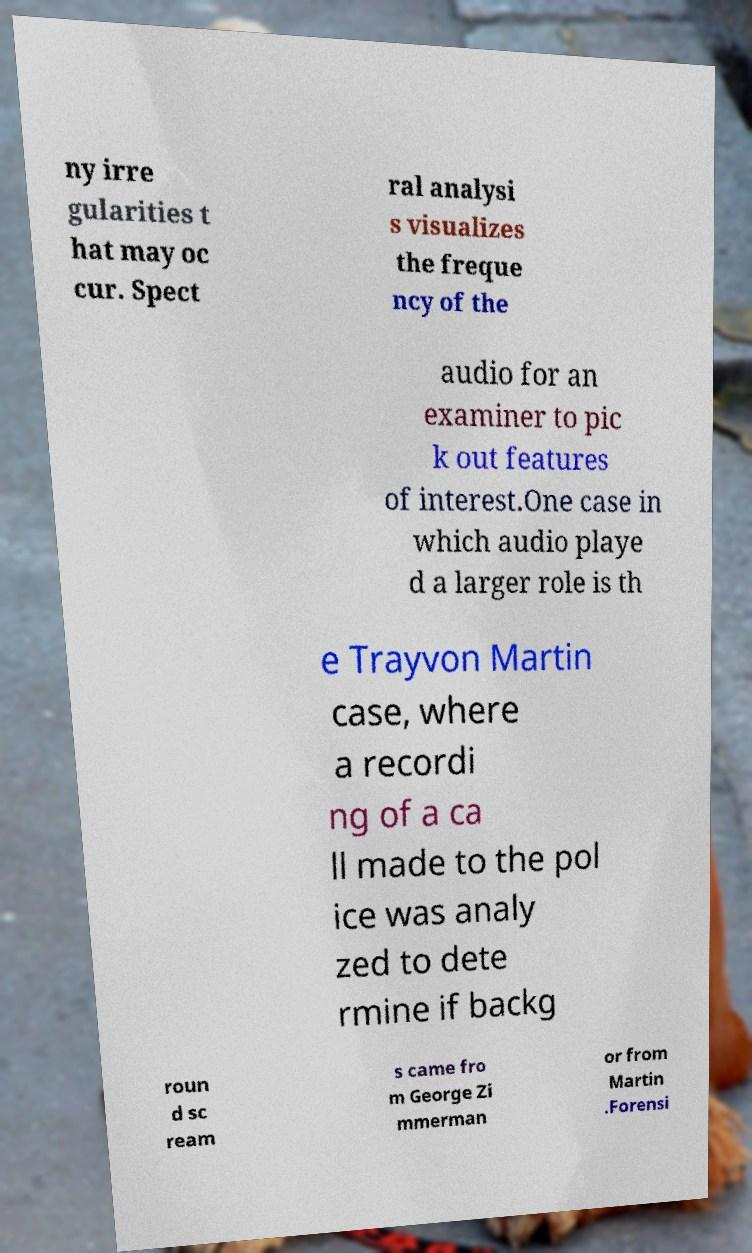Please read and relay the text visible in this image. What does it say? ny irre gularities t hat may oc cur. Spect ral analysi s visualizes the freque ncy of the audio for an examiner to pic k out features of interest.One case in which audio playe d a larger role is th e Trayvon Martin case, where a recordi ng of a ca ll made to the pol ice was analy zed to dete rmine if backg roun d sc ream s came fro m George Zi mmerman or from Martin .Forensi 